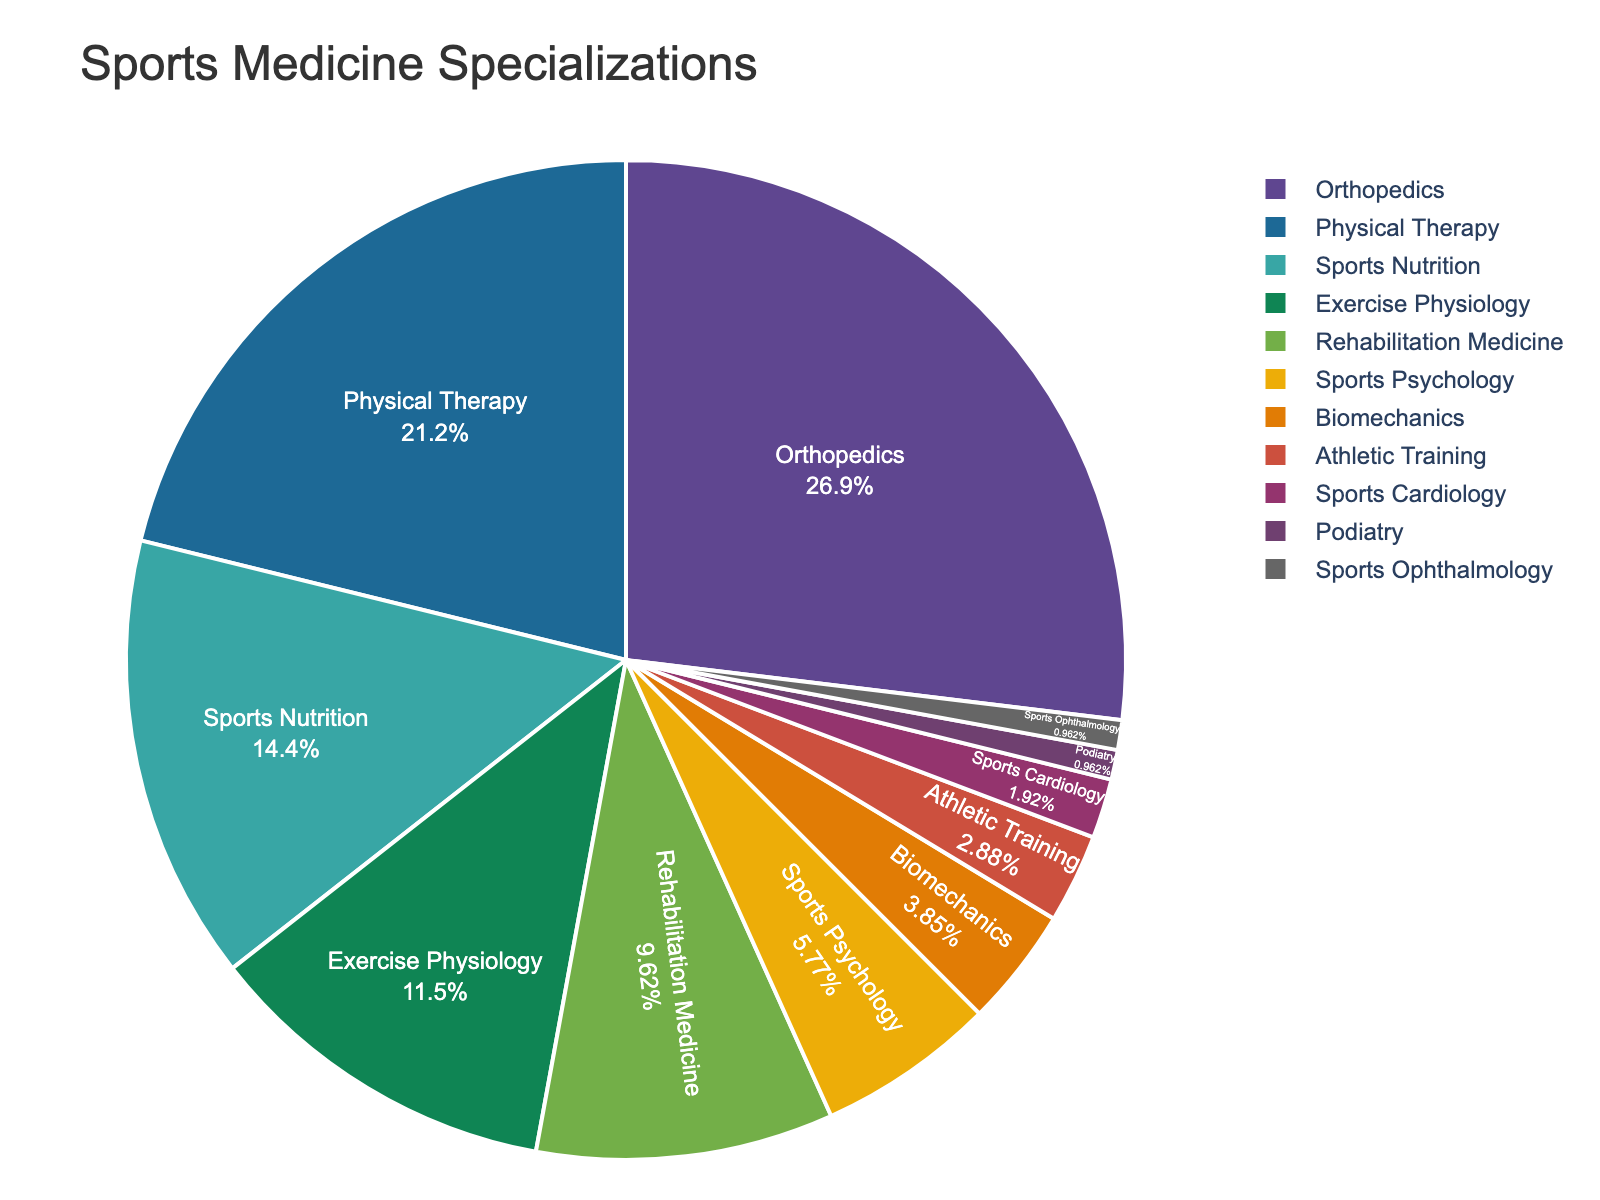What percentage of sports medicine professionals specialize in the top three areas? The top three areas of specialization by percentage are Orthopedics (28%), Physical Therapy (22%), and Sports Nutrition (15%). Summing these percentages: 28% + 22% + 15% = 65%.
Answer: 65% What's the percentage difference between Orthopedics and Sports Nutrition specialists? Orthopedics specialists make up 28% and Sports Nutrition specialists make up 15%. The percentage difference is calculated as 28% - 15% = 13%.
Answer: 13% Which area has the least number of specialists, and what is the percentage? According to the figure, both Podiatry and Sports Ophthalmology have the least number of specialists, each with a percentage of 1%.
Answer: Podiatry and Sports Ophthalmology, 1% How many areas of specialization have more than 10% of professionals? The areas with more than 10% specialists are Orthopedics (28%), Physical Therapy (22%), Sports Nutrition (15%), and Exercise Physiology (12%). Counting these areas gives us 4 areas.
Answer: 4 Compare the combined percentage of Rehabilitation Medicine and Sports Psychology with Exercise Physiology. Which one is higher and by how much? Rehabilitation Medicine has 10% and Sports Psychology has 6%, giving a combined percentage of 10% + 6% = 16%. Comparing this with Exercise Physiology's 12%, we find 16% - 12% = 4%. Therefore, the combined percentage of Rehabilitation Medicine and Sports Psychology is higher by 4%.
Answer: Combined, 4% higher What is the ratio of Physical Therapy specialists to Sports Cardiology specialists? Physical Therapy specialists have a percentage of 22%, whereas Sports Cardiology specialists have 2%. The ratio is thus 22% / 2% = 11.
Answer: 11 Are there more specialists in Biomechanics or Athletic Training, and by how much? Biomechanics specialists make up 4%, and Athletic Training specialists make up 3%. The difference is calculated as 4% - 3% = 1%. Thus, there are 1% more specialists in Biomechanics than in Athletic Training.
Answer: Biomechanics, by 1% Which specialization has a percentage closest to the average percentage of all listed specializations? Calculating the average percentage involves summing all percentages: 28 + 22 + 15 + 12 + 10 + 6 + 4 + 3 + 2 + 1 + 1 = 104. Then, dividing by the number of areas, 104/11 ≈ 9.45%. The closest specialization percentage to 9.45% is Rehabilitation Medicine with 10%.
Answer: Rehabilitation Medicine List all areas of specialization with less than 5% of sports medicine professionals. The areas with less than 5% are Sports Psychology (6%), Biomechanics (4%), Athletic Training (3%), Sports Cardiology (2%), Podiatry (1%), and Sports Ophthalmology (1%).
Answer: Biomechanics, Athletic Training, Sports Cardiology, Podiatry, Sports Ophthalmology What is the combined percentage of specialists in Exercise Physiology, Rehabilitation Medicine, and Sports Psychology? Exercise Physiology makes up 12%, Rehabilitation Medicine 10%, and Sports Psychology 6%. Summing these percentages: 12% + 10% + 6% = 28%.
Answer: 28% 